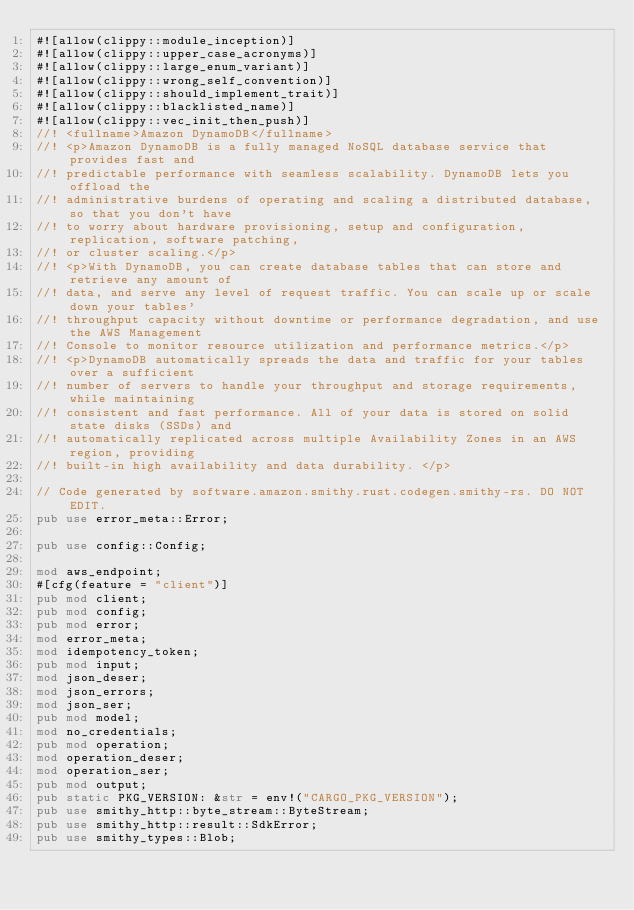Convert code to text. <code><loc_0><loc_0><loc_500><loc_500><_Rust_>#![allow(clippy::module_inception)]
#![allow(clippy::upper_case_acronyms)]
#![allow(clippy::large_enum_variant)]
#![allow(clippy::wrong_self_convention)]
#![allow(clippy::should_implement_trait)]
#![allow(clippy::blacklisted_name)]
#![allow(clippy::vec_init_then_push)]
//! <fullname>Amazon DynamoDB</fullname>
//! <p>Amazon DynamoDB is a fully managed NoSQL database service that provides fast and
//! predictable performance with seamless scalability. DynamoDB lets you offload the
//! administrative burdens of operating and scaling a distributed database, so that you don't have
//! to worry about hardware provisioning, setup and configuration, replication, software patching,
//! or cluster scaling.</p>
//! <p>With DynamoDB, you can create database tables that can store and retrieve any amount of
//! data, and serve any level of request traffic. You can scale up or scale down your tables'
//! throughput capacity without downtime or performance degradation, and use the AWS Management
//! Console to monitor resource utilization and performance metrics.</p>
//! <p>DynamoDB automatically spreads the data and traffic for your tables over a sufficient
//! number of servers to handle your throughput and storage requirements, while maintaining
//! consistent and fast performance. All of your data is stored on solid state disks (SSDs) and
//! automatically replicated across multiple Availability Zones in an AWS region, providing
//! built-in high availability and data durability. </p>

// Code generated by software.amazon.smithy.rust.codegen.smithy-rs. DO NOT EDIT.
pub use error_meta::Error;

pub use config::Config;

mod aws_endpoint;
#[cfg(feature = "client")]
pub mod client;
pub mod config;
pub mod error;
mod error_meta;
mod idempotency_token;
pub mod input;
mod json_deser;
mod json_errors;
mod json_ser;
pub mod model;
mod no_credentials;
pub mod operation;
mod operation_deser;
mod operation_ser;
pub mod output;
pub static PKG_VERSION: &str = env!("CARGO_PKG_VERSION");
pub use smithy_http::byte_stream::ByteStream;
pub use smithy_http::result::SdkError;
pub use smithy_types::Blob;</code> 